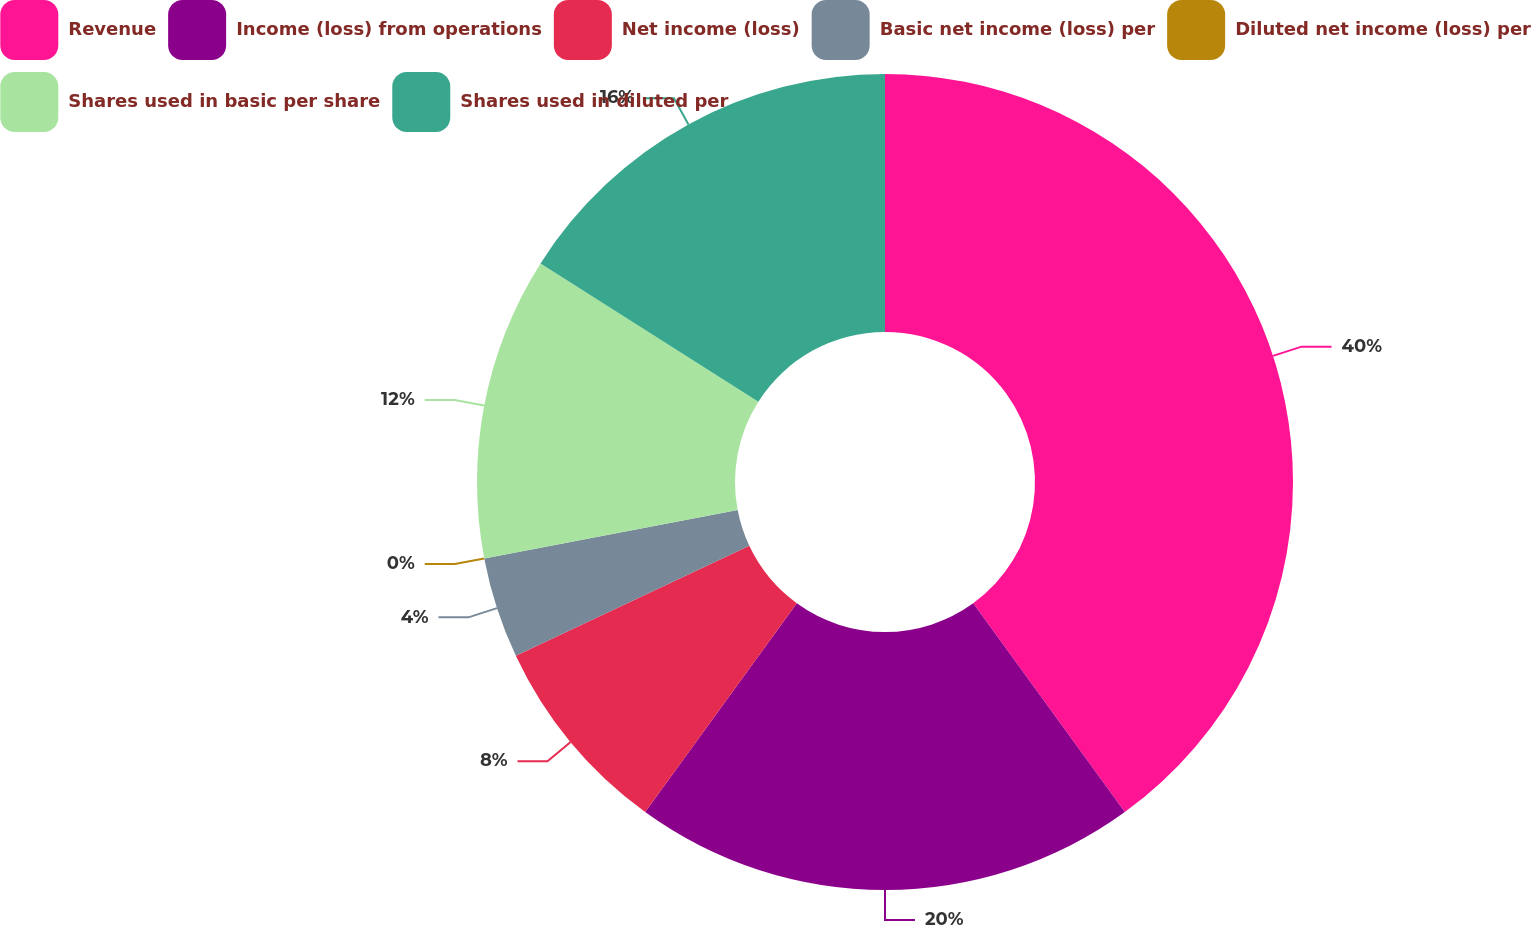Convert chart. <chart><loc_0><loc_0><loc_500><loc_500><pie_chart><fcel>Revenue<fcel>Income (loss) from operations<fcel>Net income (loss)<fcel>Basic net income (loss) per<fcel>Diluted net income (loss) per<fcel>Shares used in basic per share<fcel>Shares used in diluted per<nl><fcel>40.0%<fcel>20.0%<fcel>8.0%<fcel>4.0%<fcel>0.0%<fcel>12.0%<fcel>16.0%<nl></chart> 